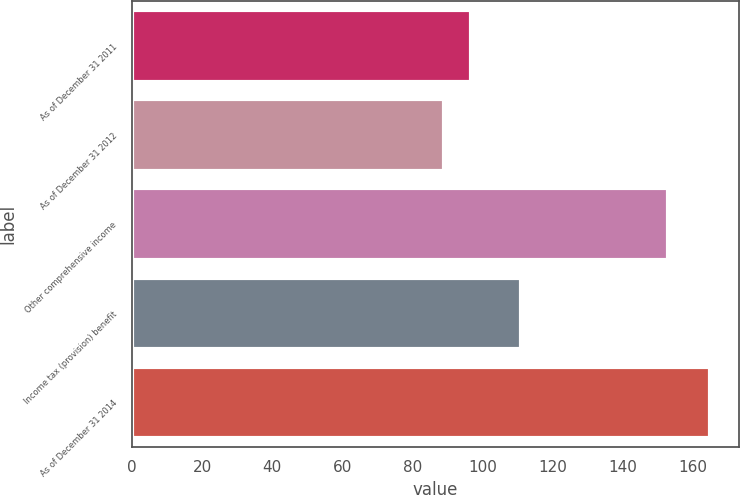Convert chart. <chart><loc_0><loc_0><loc_500><loc_500><bar_chart><fcel>As of December 31 2011<fcel>As of December 31 2012<fcel>Other comprehensive income<fcel>Income tax (provision) benefit<fcel>As of December 31 2014<nl><fcel>96.6<fcel>89<fcel>153<fcel>111<fcel>165<nl></chart> 